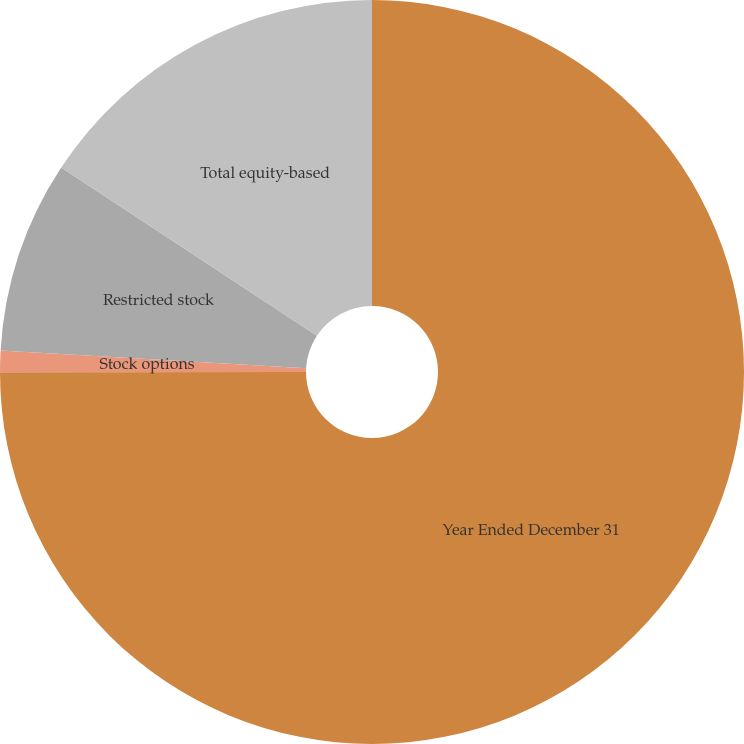Convert chart. <chart><loc_0><loc_0><loc_500><loc_500><pie_chart><fcel>Year Ended December 31<fcel>Stock options<fcel>Restricted stock<fcel>Total equity-based<nl><fcel>74.99%<fcel>0.93%<fcel>8.34%<fcel>15.74%<nl></chart> 